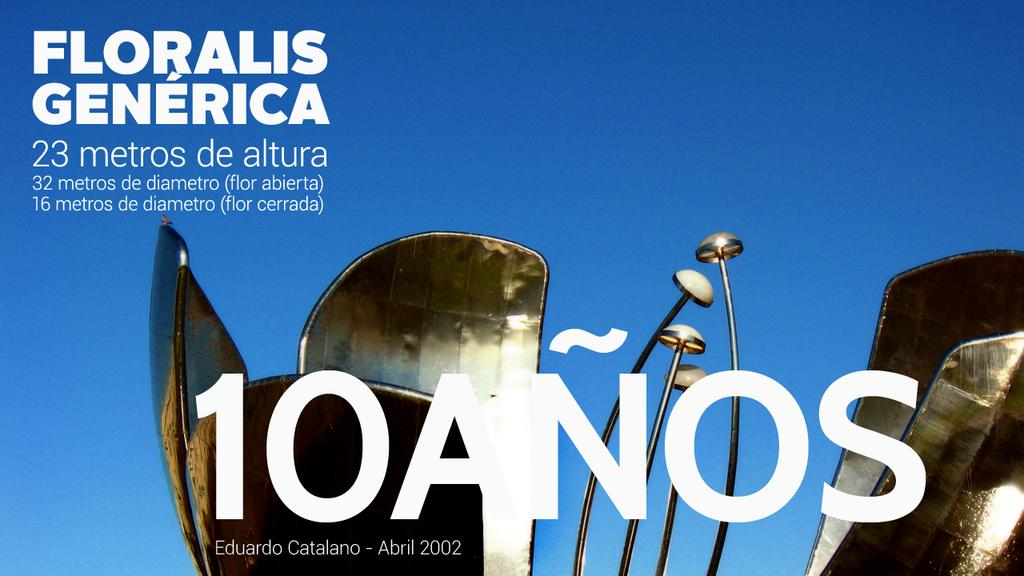<image>
Create a compact narrative representing the image presented. A foreign language with Floralis Generica with some form of sculpture 